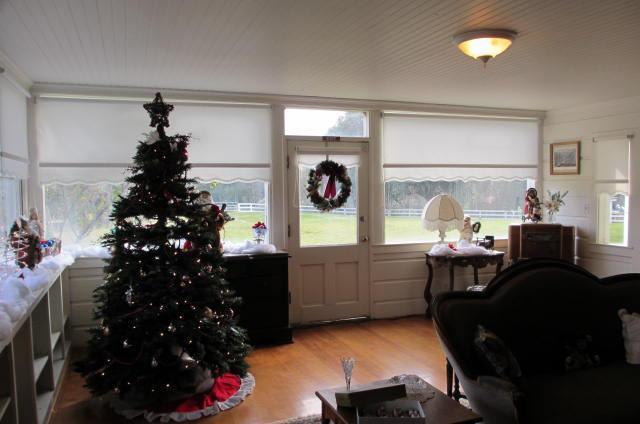How many train lights are turned on in this image?
Give a very brief answer. 0. 